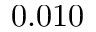Convert formula to latex. <formula><loc_0><loc_0><loc_500><loc_500>0 . 0 1 0</formula> 